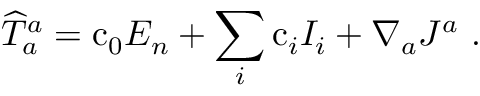Convert formula to latex. <formula><loc_0><loc_0><loc_500><loc_500>{ \widehat { T } } _ { a } ^ { a } = c _ { 0 } E _ { n } + \sum _ { i } c _ { i } I _ { i } + \nabla _ { a } J ^ { a } \ .</formula> 